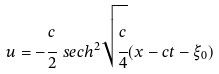<formula> <loc_0><loc_0><loc_500><loc_500>u = - \cfrac { c } { 2 } \ s e c h ^ { 2 } \sqrt { \cfrac { c } { 4 } } ( x - c t - \xi _ { 0 } )</formula> 